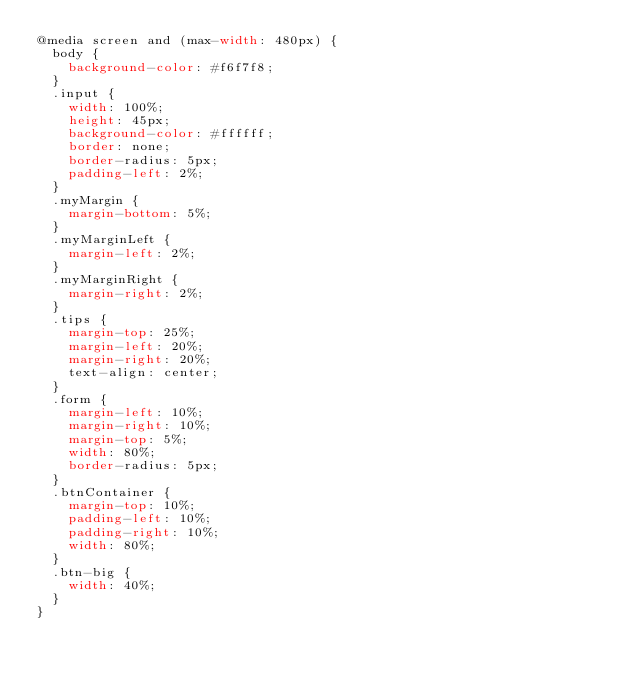<code> <loc_0><loc_0><loc_500><loc_500><_CSS_>@media screen and (max-width: 480px) {
  body {
    background-color: #f6f7f8;
  }
  .input {
    width: 100%;
    height: 45px;
    background-color: #ffffff;
    border: none;
    border-radius: 5px;
    padding-left: 2%;
  }
  .myMargin {
    margin-bottom: 5%;
  }
  .myMarginLeft {
    margin-left: 2%;
  }
  .myMarginRight {
    margin-right: 2%;
  }
  .tips {
    margin-top: 25%;
    margin-left: 20%;
    margin-right: 20%;
    text-align: center;
  }
  .form {
    margin-left: 10%;
    margin-right: 10%;
    margin-top: 5%;
    width: 80%;
    border-radius: 5px;
  }
  .btnContainer {
    margin-top: 10%;
    padding-left: 10%;
    padding-right: 10%;
    width: 80%;
  }
  .btn-big {
    width: 40%;
  }
}
</code> 